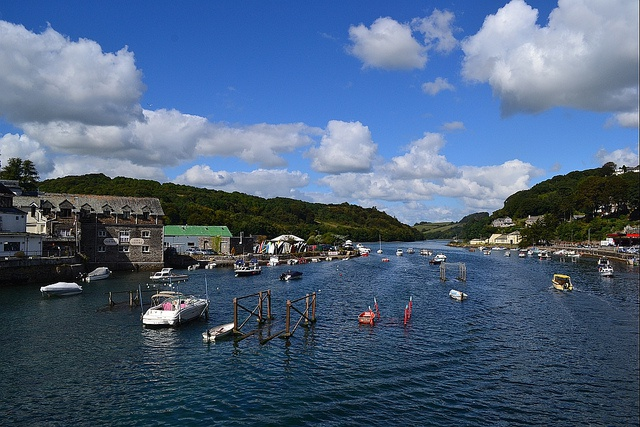Describe the objects in this image and their specific colors. I can see boat in blue, white, black, gray, and darkgray tones, boat in blue, black, lightgray, darkgray, and gray tones, boat in blue, black, gray, darkgray, and navy tones, boat in blue, white, gray, darkgray, and black tones, and boat in blue, black, gray, darkgray, and lightgray tones in this image. 